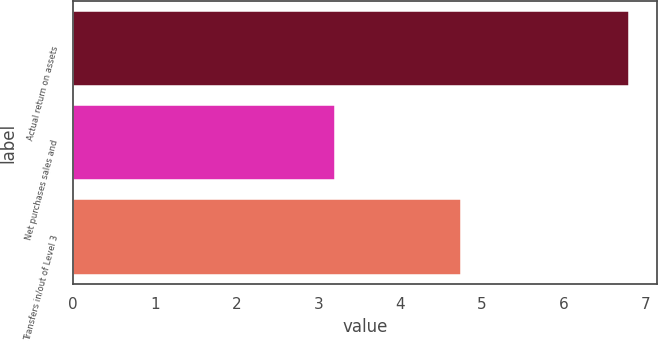<chart> <loc_0><loc_0><loc_500><loc_500><bar_chart><fcel>Actual return on assets<fcel>Net purchases sales and<fcel>Transfers in/out of Level 3<nl><fcel>6.8<fcel>3.2<fcel>4.75<nl></chart> 